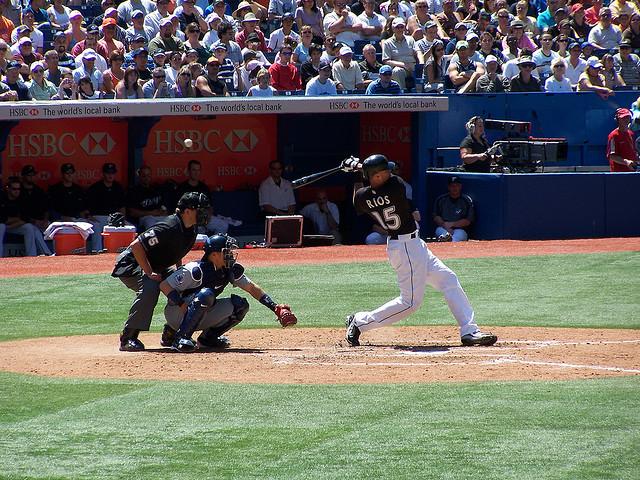Is the batter left handed?
Be succinct. Yes. Are these people playing for money?
Quick response, please. Yes. What logo is on the wall of the dugout?
Answer briefly. Hsbc. 